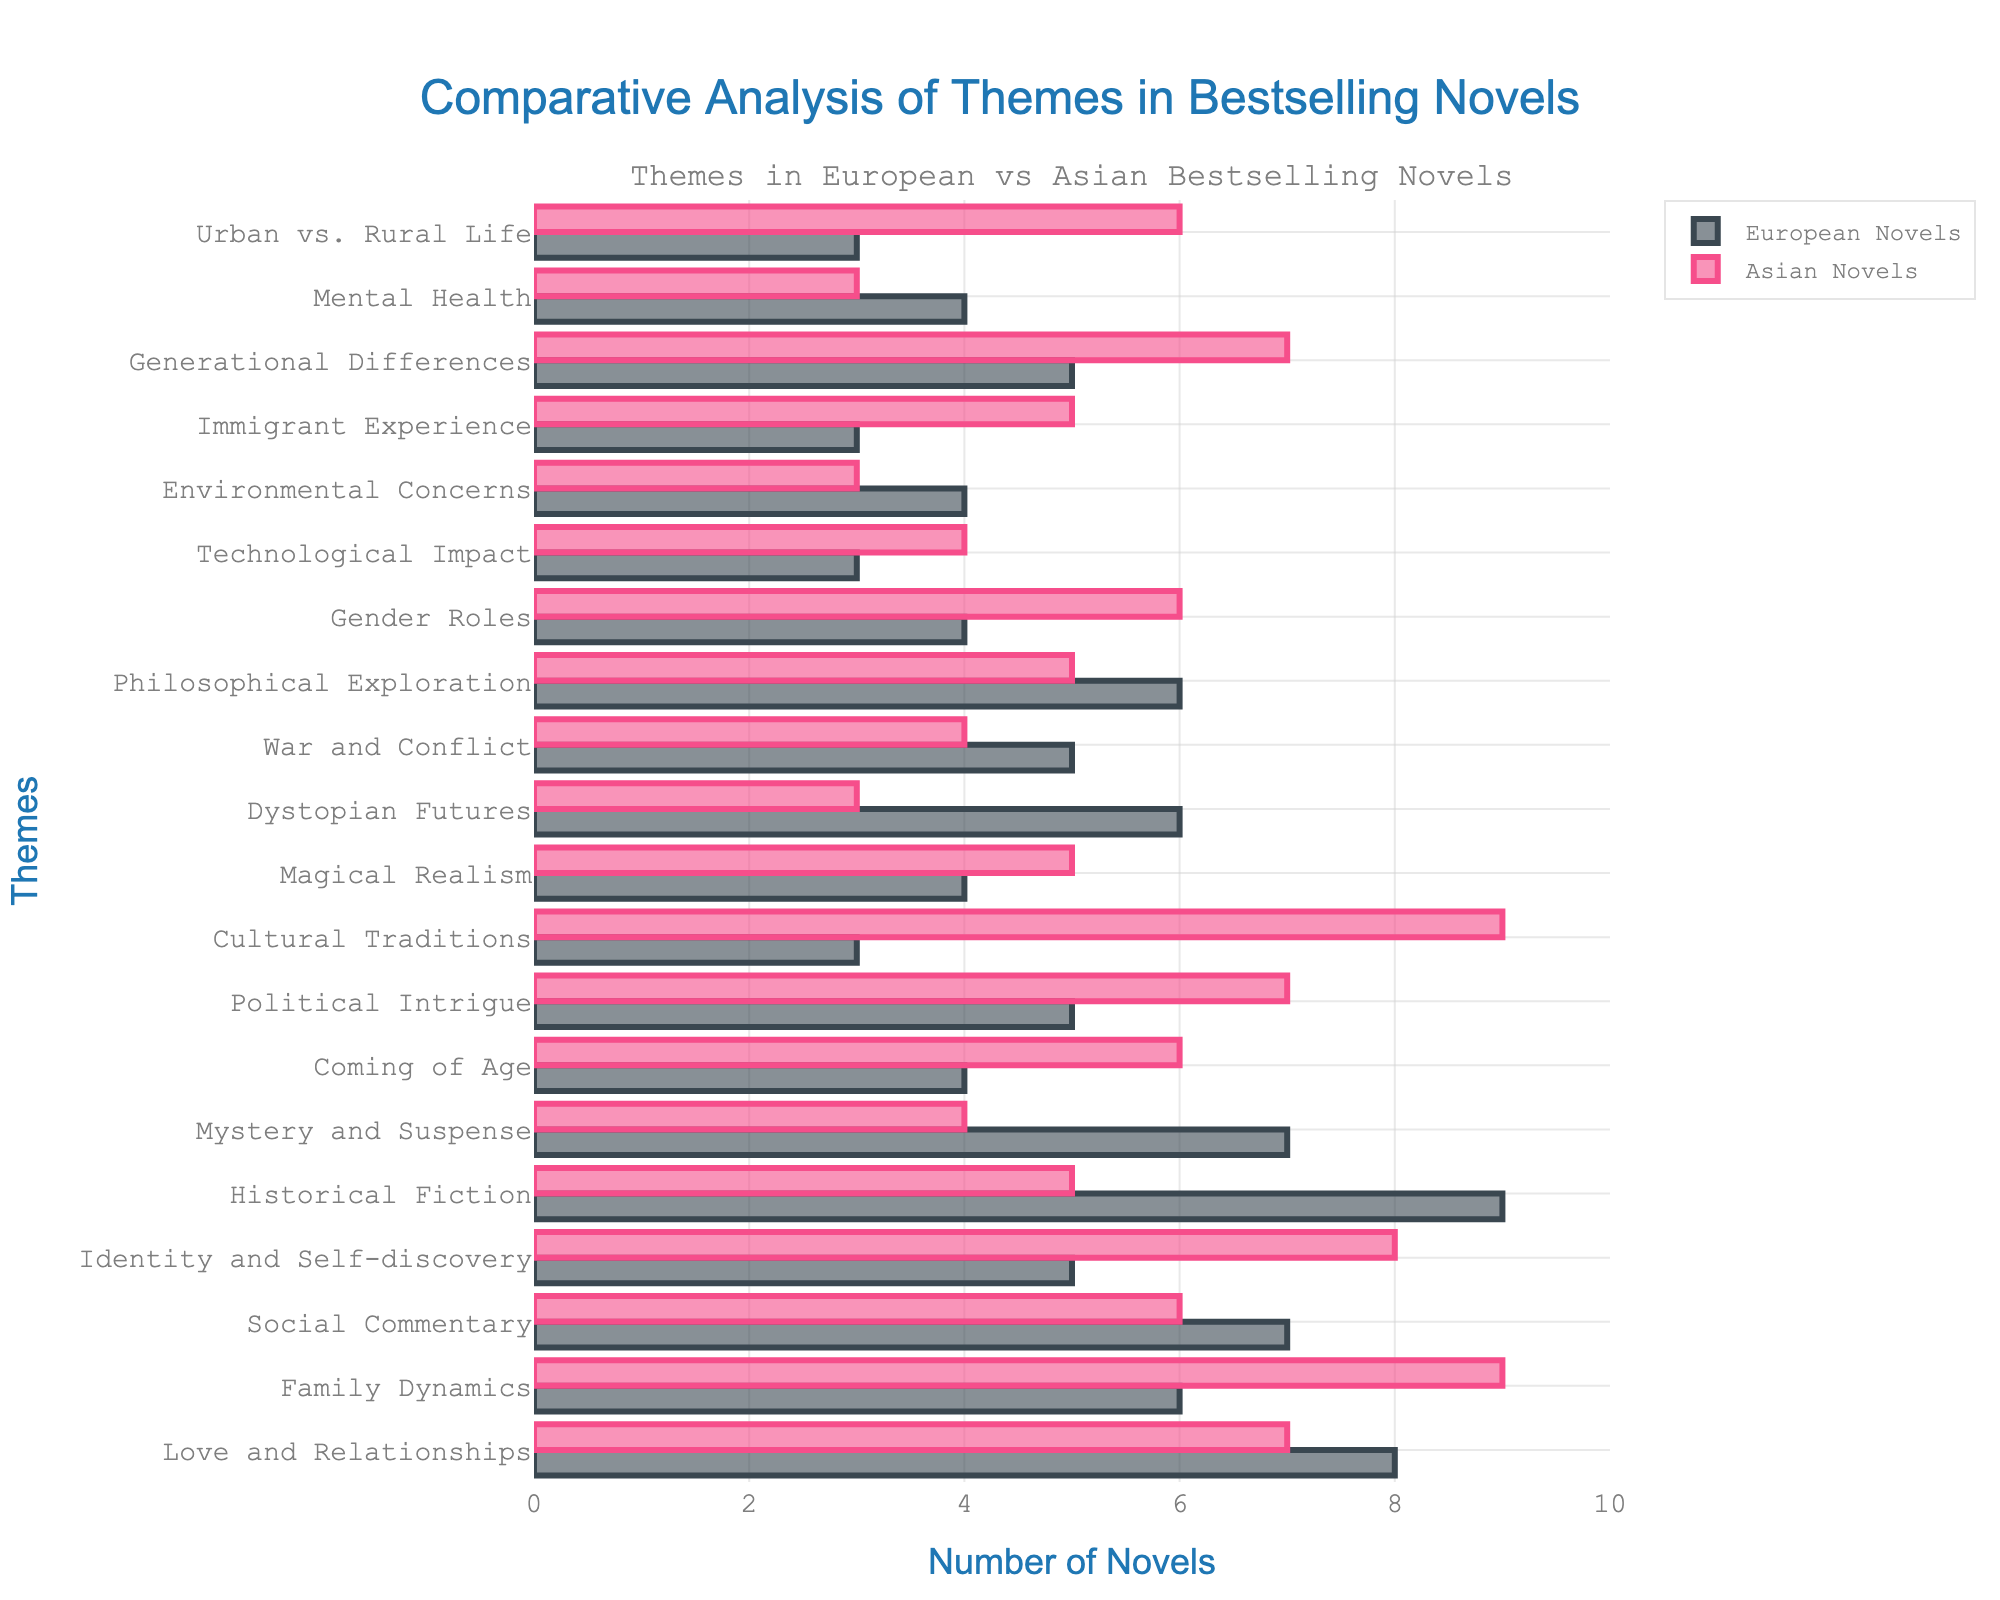Which theme is more prominent in European novels compared to Asian novels? By comparing the lengths of the bars for each theme between 'European Novels' and 'Asian Novels', we can observe that 'Historical Fiction' is significantly more prominent in European novels (9) compared to Asian novels (5).
Answer: Historical Fiction Which theme appears more frequently in Asian novels compared to European novels? By comparing the lengths of the bars for each theme, we can observe that 'Cultural Traditions' appears more frequently in Asian novels (9) compared to European novels (3).
Answer: Cultural Traditions How many more novels focus on 'Family Dynamics' in Asian literature compared to European literature? We look at the bars for 'Family Dynamics' and see the count for Asian novels is 9 and for European novels is 6. The difference is 9 - 6 = 3.
Answer: 3 Which two themes have an equal count of novels in both European and Asian literature? We compare the bars for each theme for both regions. Both 'War and Conflict' (5 each) and 'Social Commentary' (7 each) have equal counts in European and Asian literature.
Answer: War and Conflict, Social Commentary What is the average number of European novels featuring 'Technological Impact', 'Environmental Concerns', and 'Immigrant Experience'? The counts are 3 (Technological Impact), 4 (Environmental Concerns), and 3 (Immigrant Experience). Their sum is 3 + 4 + 3 = 10. The average is 10 / 3 ≈ 3.33.
Answer: 3.33 Which theme shows the greatest difference in prominence between European and Asian novels? By visually comparing the differences in the lengths of the bars, 'Cultural Traditions' shows the greatest difference with a difference of 9 (Asian) - 3 (European) = 6.
Answer: Cultural Traditions How many themes have a higher count in European novels than in Asian novels? By counting the themes where the bars for European novels are longer, we find: 'Love and Relationships', 'Social Commentary,' 'Historical Fiction,' 'Mystery and Suspense,' 'Dystopian Futures,' 'War and Conflict,' and 'Philosophical Exploration'. There are 7 such themes.
Answer: 7 What's the total number of European novels that focus on 'Love and Relationships', 'Mystery and Suspense', and 'Dystopian Futures'? The counts are 8 (Love and Relationships), 7 (Mystery and Suspense), and 6 (Dystopian Futures). Their sum is 8 + 7 + 6 = 21.
Answer: 21 Which theme has equal prominence in both European and Asian novels and also focuses on an individual's inner life? 'Identity and Self-discovery' focuses on an individual's inner life. By comparing counts, it is equally high in Asian novels (8) compared to European novels (5).
Answer: None What are the counts for 'Coming of Age' in European and Asian novels, and which is higher? The counts for 'Coming of Age' are 4 in European novels and 6 in Asian novels. Asian novels have a higher count.
Answer: 4 (European), 6 (Asian), Asian is higher 